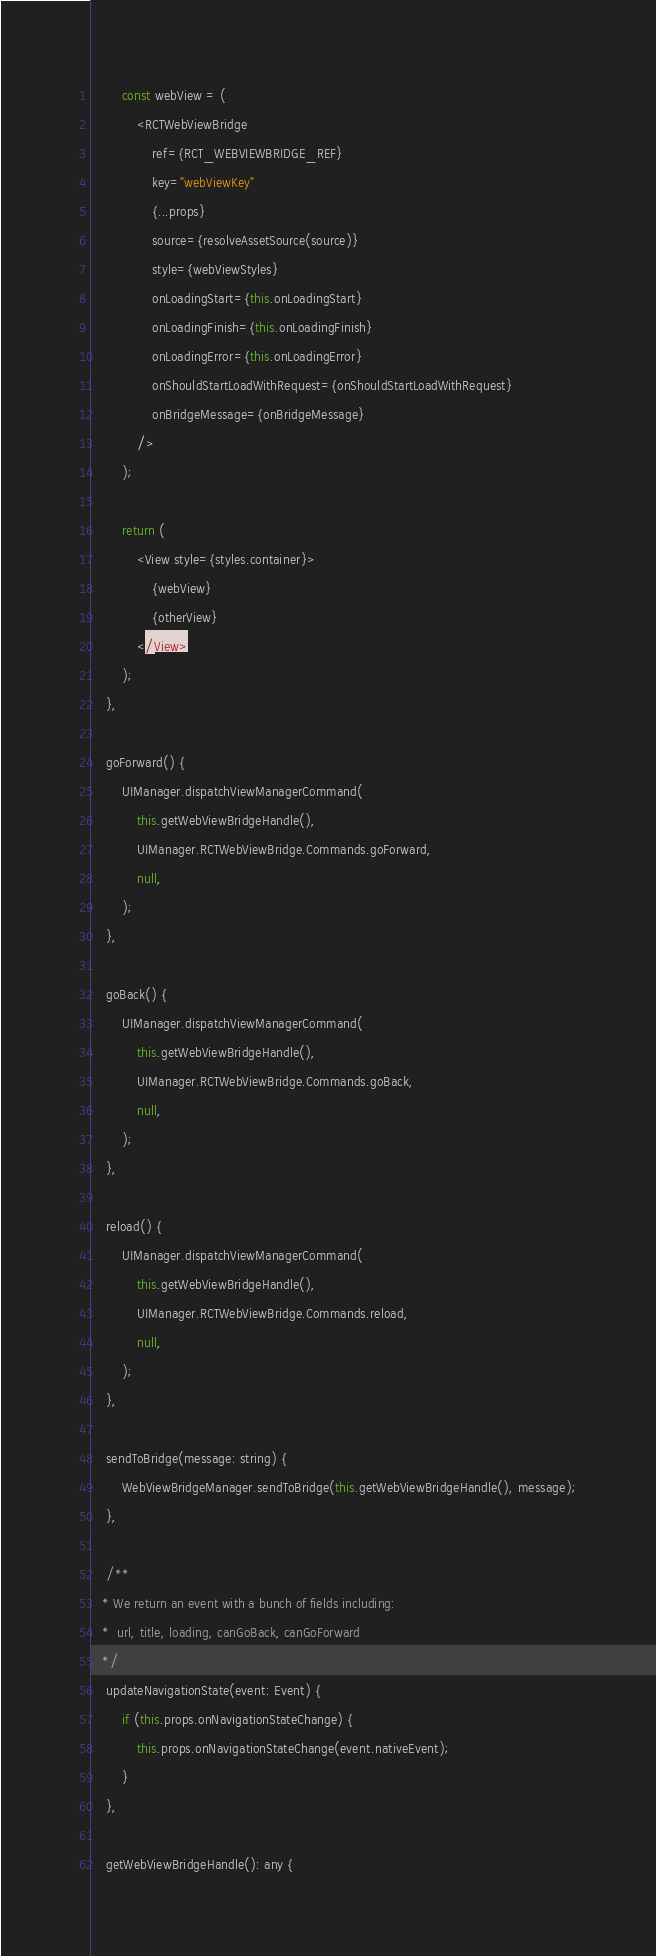Convert code to text. <code><loc_0><loc_0><loc_500><loc_500><_JavaScript_>        const webView = (
            <RCTWebViewBridge
                ref={RCT_WEBVIEWBRIDGE_REF}
                key="webViewKey"
                {...props}
                source={resolveAssetSource(source)}
                style={webViewStyles}
                onLoadingStart={this.onLoadingStart}
                onLoadingFinish={this.onLoadingFinish}
                onLoadingError={this.onLoadingError}
                onShouldStartLoadWithRequest={onShouldStartLoadWithRequest}
                onBridgeMessage={onBridgeMessage}
            />
        );

        return (
            <View style={styles.container}>
                {webView}
                {otherView}
            </View>
        );
    },

    goForward() {
        UIManager.dispatchViewManagerCommand(
            this.getWebViewBridgeHandle(),
            UIManager.RCTWebViewBridge.Commands.goForward,
            null,
        );
    },

    goBack() {
        UIManager.dispatchViewManagerCommand(
            this.getWebViewBridgeHandle(),
            UIManager.RCTWebViewBridge.Commands.goBack,
            null,
        );
    },

    reload() {
        UIManager.dispatchViewManagerCommand(
            this.getWebViewBridgeHandle(),
            UIManager.RCTWebViewBridge.Commands.reload,
            null,
        );
    },

    sendToBridge(message: string) {
        WebViewBridgeManager.sendToBridge(this.getWebViewBridgeHandle(), message);
    },

    /**
   * We return an event with a bunch of fields including:
   *  url, title, loading, canGoBack, canGoForward
   */
    updateNavigationState(event: Event) {
        if (this.props.onNavigationStateChange) {
            this.props.onNavigationStateChange(event.nativeEvent);
        }
    },

    getWebViewBridgeHandle(): any {</code> 